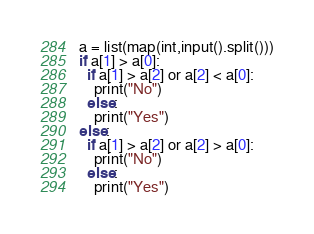Convert code to text. <code><loc_0><loc_0><loc_500><loc_500><_Python_>a = list(map(int,input().split()))
if a[1] > a[0]:
  if a[1] > a[2] or a[2] < a[0]:
    print("No")
  else:
  	print("Yes")
else:
  if a[1] > a[2] or a[2] > a[0]:
    print("No")
  else:
    print("Yes")</code> 